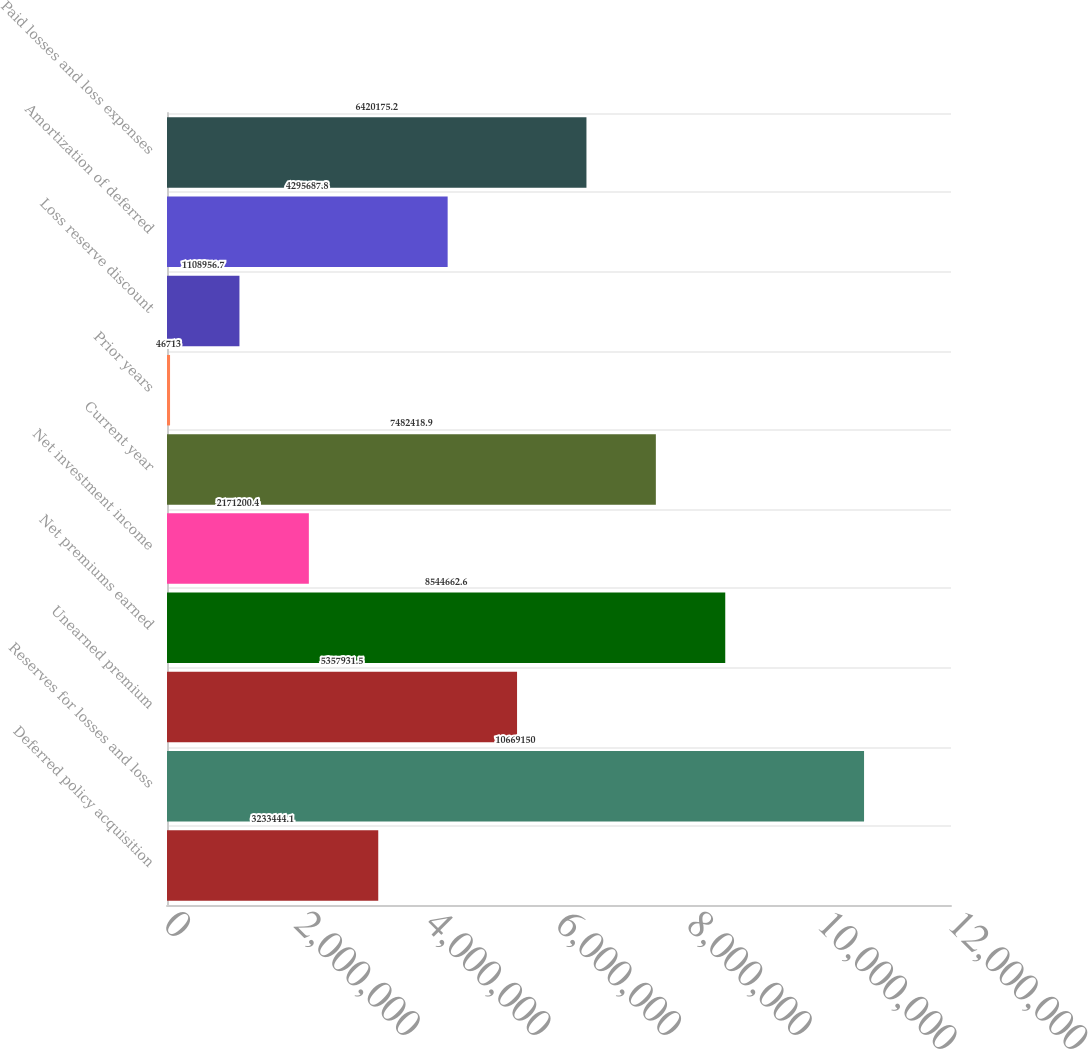<chart> <loc_0><loc_0><loc_500><loc_500><bar_chart><fcel>Deferred policy acquisition<fcel>Reserves for losses and loss<fcel>Unearned premium<fcel>Net premiums earned<fcel>Net investment income<fcel>Current year<fcel>Prior years<fcel>Loss reserve discount<fcel>Amortization of deferred<fcel>Paid losses and loss expenses<nl><fcel>3.23344e+06<fcel>1.06692e+07<fcel>5.35793e+06<fcel>8.54466e+06<fcel>2.1712e+06<fcel>7.48242e+06<fcel>46713<fcel>1.10896e+06<fcel>4.29569e+06<fcel>6.42018e+06<nl></chart> 